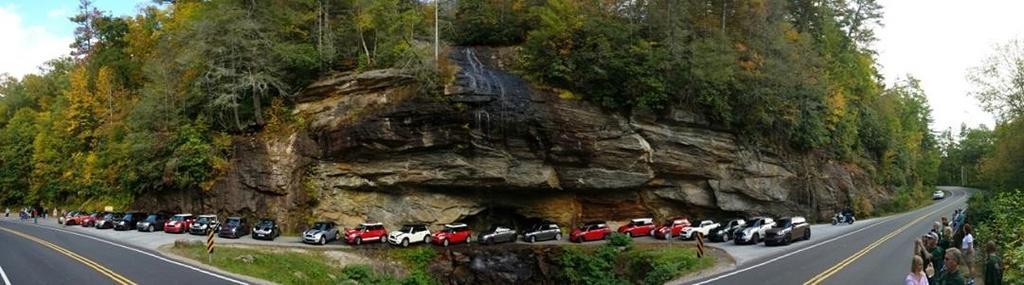Can you describe this image briefly? In the center of the image we can see a few vehicles, two poles, grass, plants, road and a few people are standing. At the bottom right side of the image, we can see a few people are standing and they are in different costumes. In the background we can see the sky, clouds, trees, on hill stone and a few other objects. 